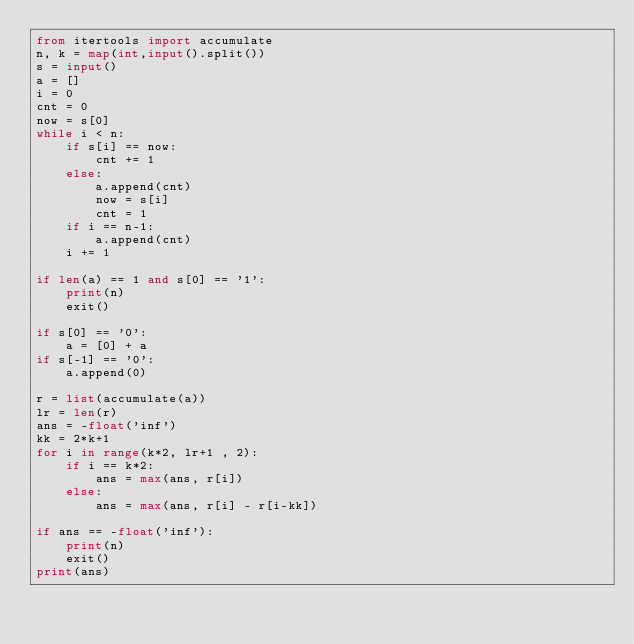Convert code to text. <code><loc_0><loc_0><loc_500><loc_500><_Python_>from itertools import accumulate
n, k = map(int,input().split())
s = input()
a = []
i = 0
cnt = 0
now = s[0]
while i < n:
    if s[i] == now:
        cnt += 1
    else:
        a.append(cnt)
        now = s[i]
        cnt = 1
    if i == n-1:
        a.append(cnt)
    i += 1

if len(a) == 1 and s[0] == '1':
    print(n)
    exit()

if s[0] == '0':
    a = [0] + a
if s[-1] == '0':
    a.append(0)
    
r = list(accumulate(a))
lr = len(r)
ans = -float('inf')
kk = 2*k+1
for i in range(k*2, lr+1 , 2):
    if i == k*2:
        ans = max(ans, r[i])
    else:
        ans = max(ans, r[i] - r[i-kk])
        
if ans == -float('inf'):
    print(n)
    exit()
print(ans)</code> 